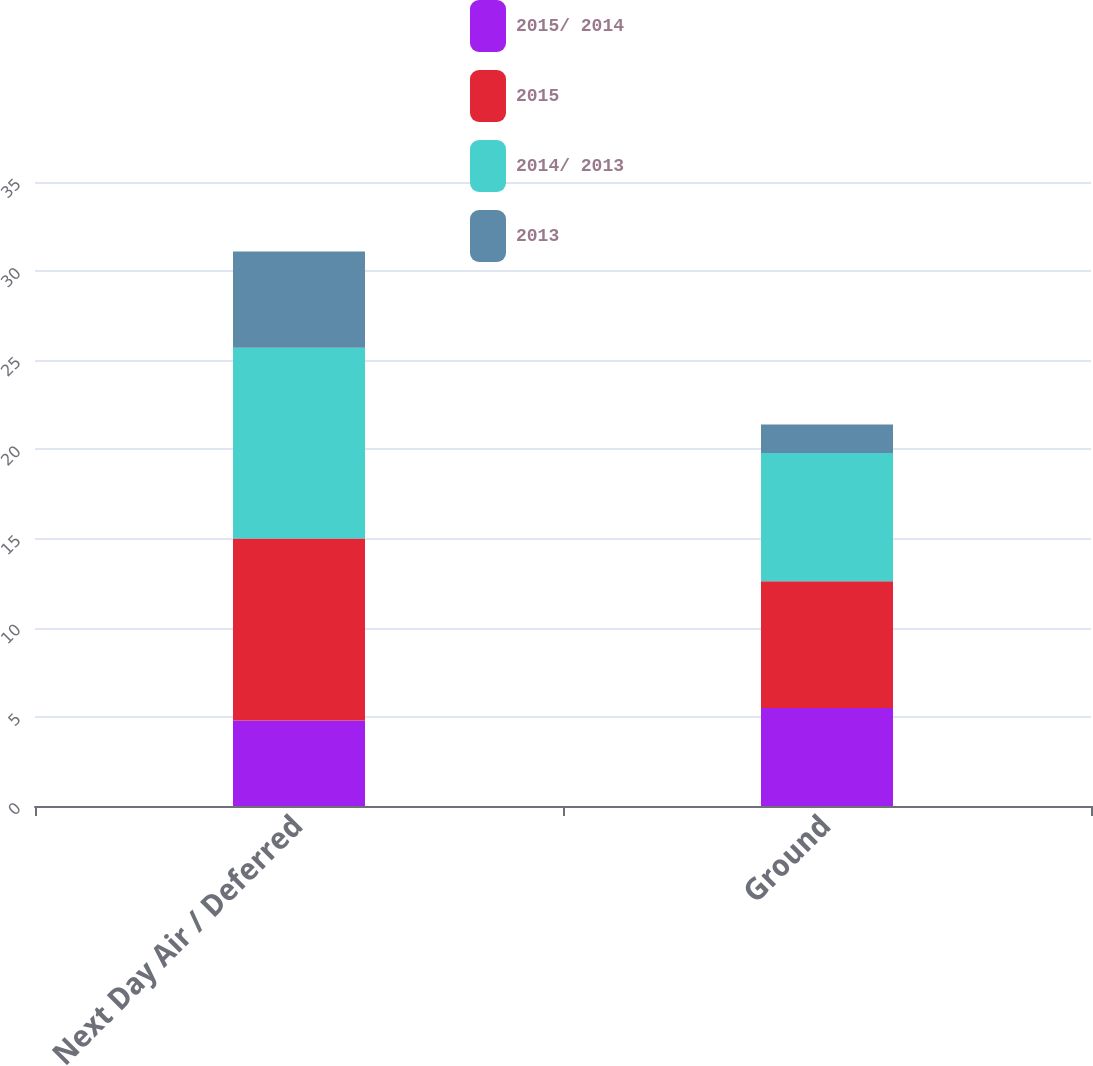Convert chart to OTSL. <chart><loc_0><loc_0><loc_500><loc_500><stacked_bar_chart><ecel><fcel>Next Day Air / Deferred<fcel>Ground<nl><fcel>2015/ 2014<fcel>4.8<fcel>5.5<nl><fcel>2015<fcel>10.2<fcel>7.1<nl><fcel>2014/ 2013<fcel>10.7<fcel>7.2<nl><fcel>2013<fcel>5.4<fcel>1.6<nl></chart> 